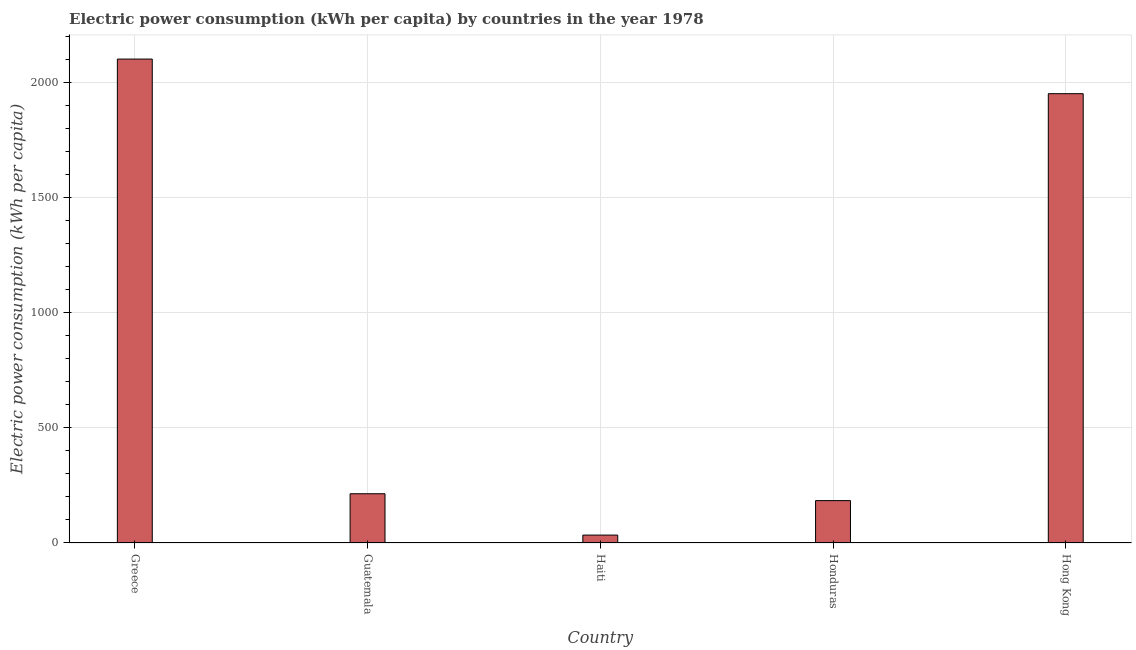Does the graph contain any zero values?
Give a very brief answer. No. Does the graph contain grids?
Your answer should be compact. Yes. What is the title of the graph?
Offer a very short reply. Electric power consumption (kWh per capita) by countries in the year 1978. What is the label or title of the Y-axis?
Offer a very short reply. Electric power consumption (kWh per capita). What is the electric power consumption in Greece?
Your answer should be compact. 2100.96. Across all countries, what is the maximum electric power consumption?
Offer a very short reply. 2100.96. Across all countries, what is the minimum electric power consumption?
Ensure brevity in your answer.  34.31. In which country was the electric power consumption maximum?
Your answer should be very brief. Greece. In which country was the electric power consumption minimum?
Offer a very short reply. Haiti. What is the sum of the electric power consumption?
Your answer should be very brief. 4483.77. What is the difference between the electric power consumption in Greece and Hong Kong?
Make the answer very short. 150.24. What is the average electric power consumption per country?
Ensure brevity in your answer.  896.75. What is the median electric power consumption?
Provide a succinct answer. 213.79. In how many countries, is the electric power consumption greater than 1100 kWh per capita?
Your answer should be compact. 2. What is the ratio of the electric power consumption in Haiti to that in Hong Kong?
Offer a terse response. 0.02. What is the difference between the highest and the second highest electric power consumption?
Provide a short and direct response. 150.24. Is the sum of the electric power consumption in Haiti and Hong Kong greater than the maximum electric power consumption across all countries?
Your answer should be very brief. No. What is the difference between the highest and the lowest electric power consumption?
Make the answer very short. 2066.66. How many bars are there?
Offer a very short reply. 5. Are all the bars in the graph horizontal?
Your answer should be very brief. No. What is the Electric power consumption (kWh per capita) in Greece?
Provide a short and direct response. 2100.96. What is the Electric power consumption (kWh per capita) in Guatemala?
Provide a succinct answer. 213.79. What is the Electric power consumption (kWh per capita) in Haiti?
Your response must be concise. 34.31. What is the Electric power consumption (kWh per capita) of Honduras?
Offer a very short reply. 183.98. What is the Electric power consumption (kWh per capita) of Hong Kong?
Give a very brief answer. 1950.72. What is the difference between the Electric power consumption (kWh per capita) in Greece and Guatemala?
Offer a very short reply. 1887.17. What is the difference between the Electric power consumption (kWh per capita) in Greece and Haiti?
Provide a short and direct response. 2066.66. What is the difference between the Electric power consumption (kWh per capita) in Greece and Honduras?
Your response must be concise. 1916.98. What is the difference between the Electric power consumption (kWh per capita) in Greece and Hong Kong?
Your answer should be compact. 150.24. What is the difference between the Electric power consumption (kWh per capita) in Guatemala and Haiti?
Offer a very short reply. 179.48. What is the difference between the Electric power consumption (kWh per capita) in Guatemala and Honduras?
Give a very brief answer. 29.81. What is the difference between the Electric power consumption (kWh per capita) in Guatemala and Hong Kong?
Provide a short and direct response. -1736.93. What is the difference between the Electric power consumption (kWh per capita) in Haiti and Honduras?
Your answer should be very brief. -149.67. What is the difference between the Electric power consumption (kWh per capita) in Haiti and Hong Kong?
Keep it short and to the point. -1916.41. What is the difference between the Electric power consumption (kWh per capita) in Honduras and Hong Kong?
Give a very brief answer. -1766.74. What is the ratio of the Electric power consumption (kWh per capita) in Greece to that in Guatemala?
Give a very brief answer. 9.83. What is the ratio of the Electric power consumption (kWh per capita) in Greece to that in Haiti?
Keep it short and to the point. 61.24. What is the ratio of the Electric power consumption (kWh per capita) in Greece to that in Honduras?
Your answer should be compact. 11.42. What is the ratio of the Electric power consumption (kWh per capita) in Greece to that in Hong Kong?
Provide a succinct answer. 1.08. What is the ratio of the Electric power consumption (kWh per capita) in Guatemala to that in Haiti?
Offer a terse response. 6.23. What is the ratio of the Electric power consumption (kWh per capita) in Guatemala to that in Honduras?
Offer a terse response. 1.16. What is the ratio of the Electric power consumption (kWh per capita) in Guatemala to that in Hong Kong?
Offer a terse response. 0.11. What is the ratio of the Electric power consumption (kWh per capita) in Haiti to that in Honduras?
Your response must be concise. 0.19. What is the ratio of the Electric power consumption (kWh per capita) in Haiti to that in Hong Kong?
Provide a short and direct response. 0.02. What is the ratio of the Electric power consumption (kWh per capita) in Honduras to that in Hong Kong?
Give a very brief answer. 0.09. 